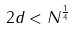Convert formula to latex. <formula><loc_0><loc_0><loc_500><loc_500>2 d < N ^ { \frac { 1 } { 4 } }</formula> 